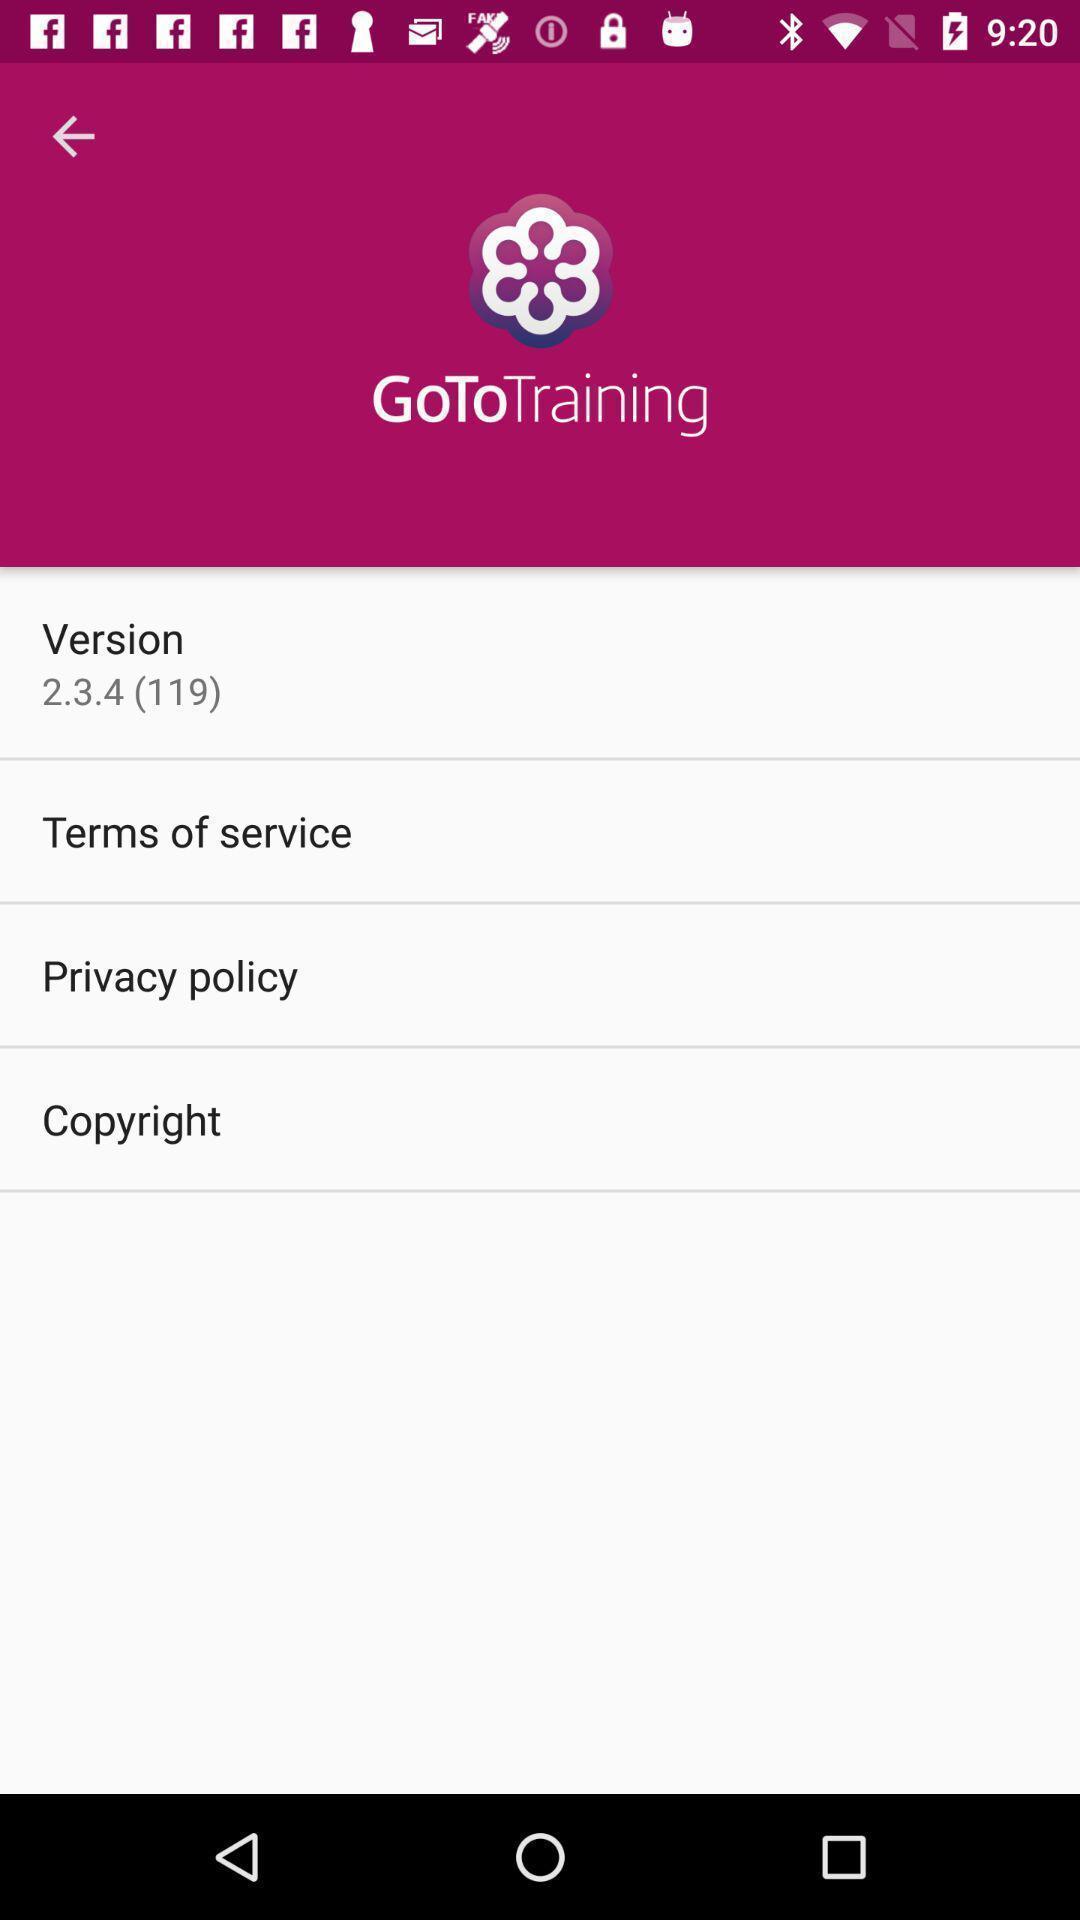Describe the key features of this screenshot. Various options in a training app. 